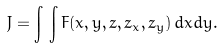<formula> <loc_0><loc_0><loc_500><loc_500>J = \int \, \int F ( x , y , z , z _ { x } , z _ { y } ) \, d x d y .</formula> 